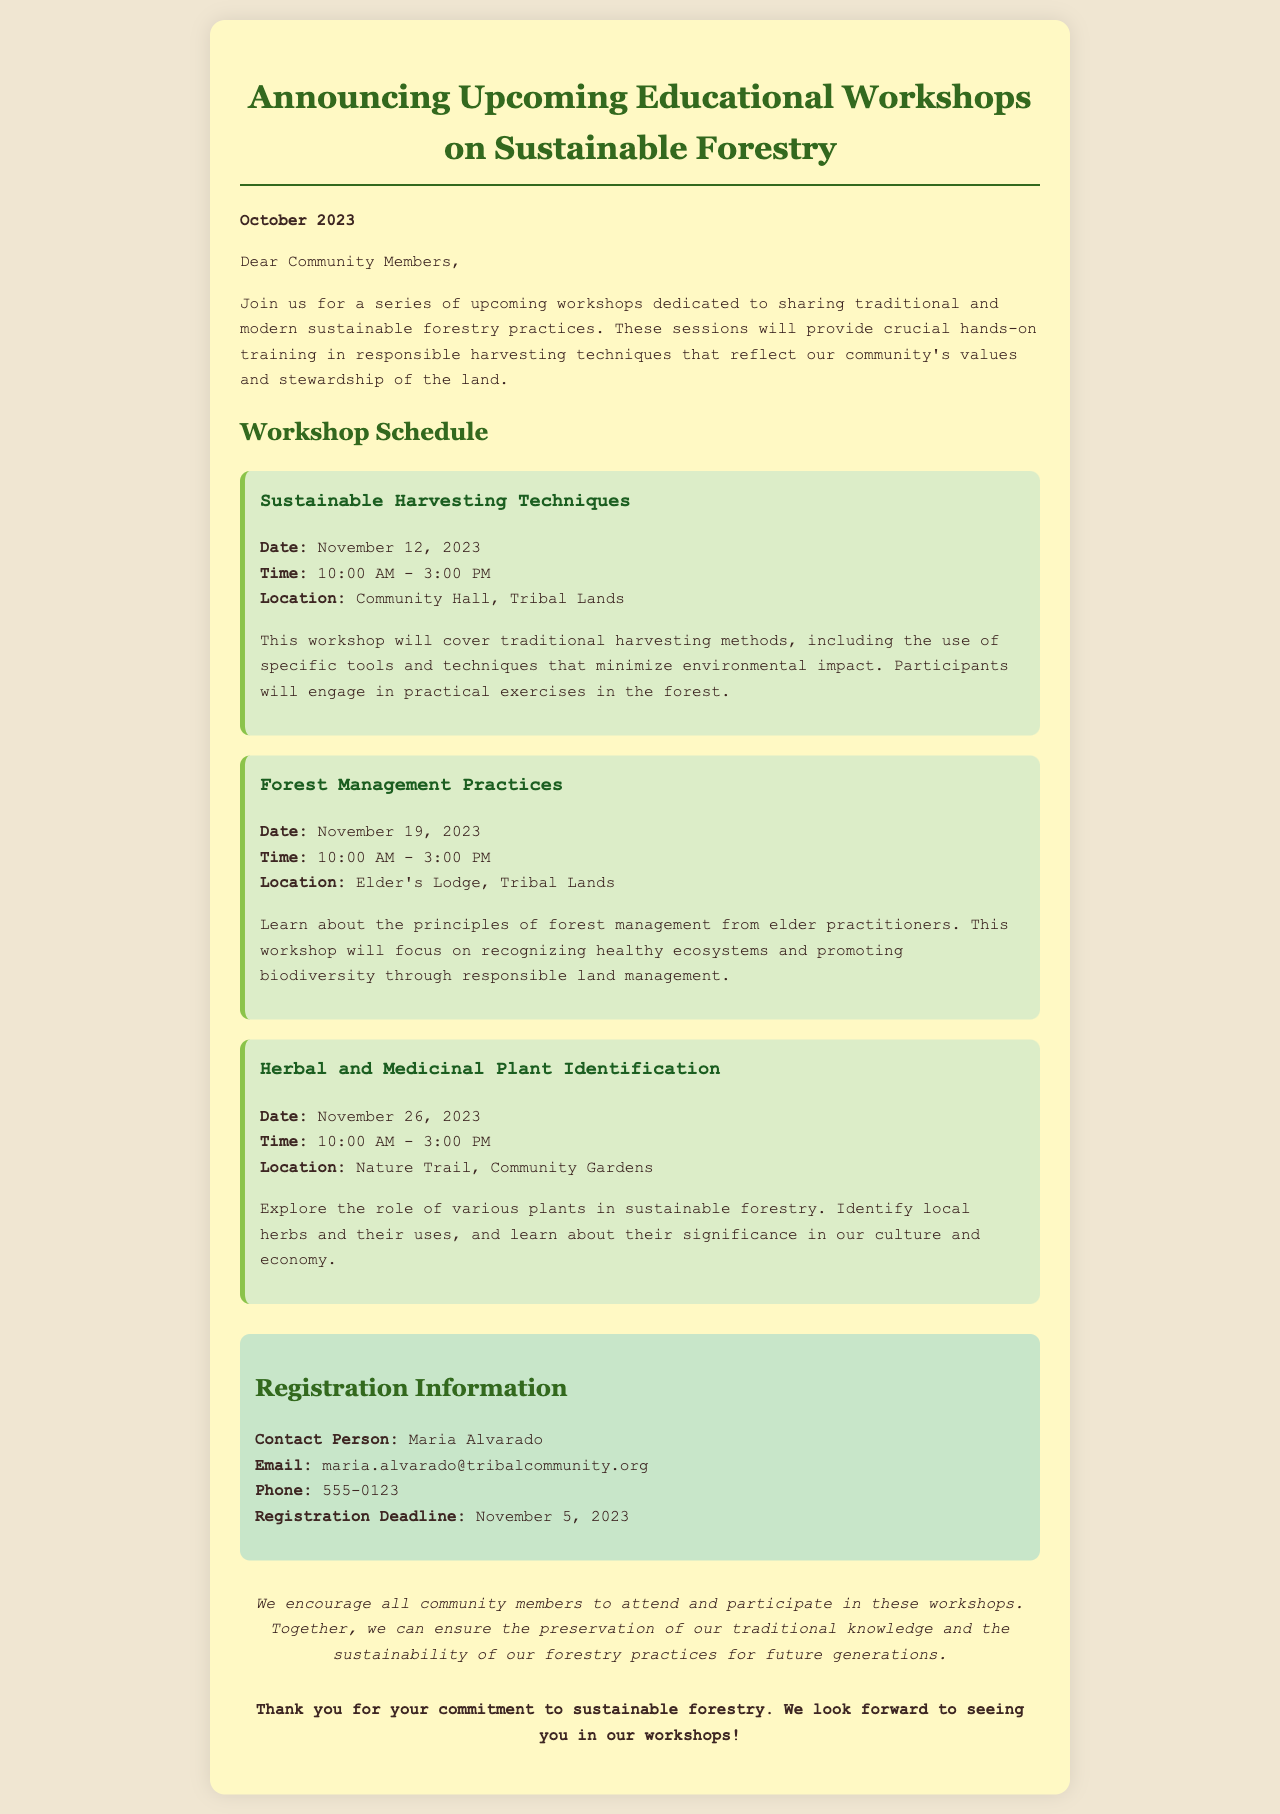what is the date of the first workshop? The date of the first workshop, "Sustainable Harvesting Techniques," is mentioned in the schedule section.
Answer: November 12, 2023 what is the location of the second workshop? The location for the second workshop, "Forest Management Practices," is specified under its details.
Answer: Elder's Lodge, Tribal Lands who is the contact person for registration? The document details the registration information, including the contact person for the workshops.
Answer: Maria Alvarado what is taught in the third workshop? The description of the third workshop outlines its main focus and content.
Answer: Herbal and Medicinal Plant Identification what is the registration deadline? The registration information section clearly states the deadline for signing up for the workshops.
Answer: November 5, 2023 how long is each workshop scheduled to last? The workshops are all scheduled for the same time duration, which is indicated in the schedule section.
Answer: 5 hours why is it important for community members to attend these workshops? The outreach section emphasizes the significance of participation for preserving knowledge and sustainability.
Answer: Preservation of traditional knowledge when will the workshops take place? The workshops are all scheduled for specific dates in November, indicated in the document.
Answer: November 12, 19, 26, 2023 